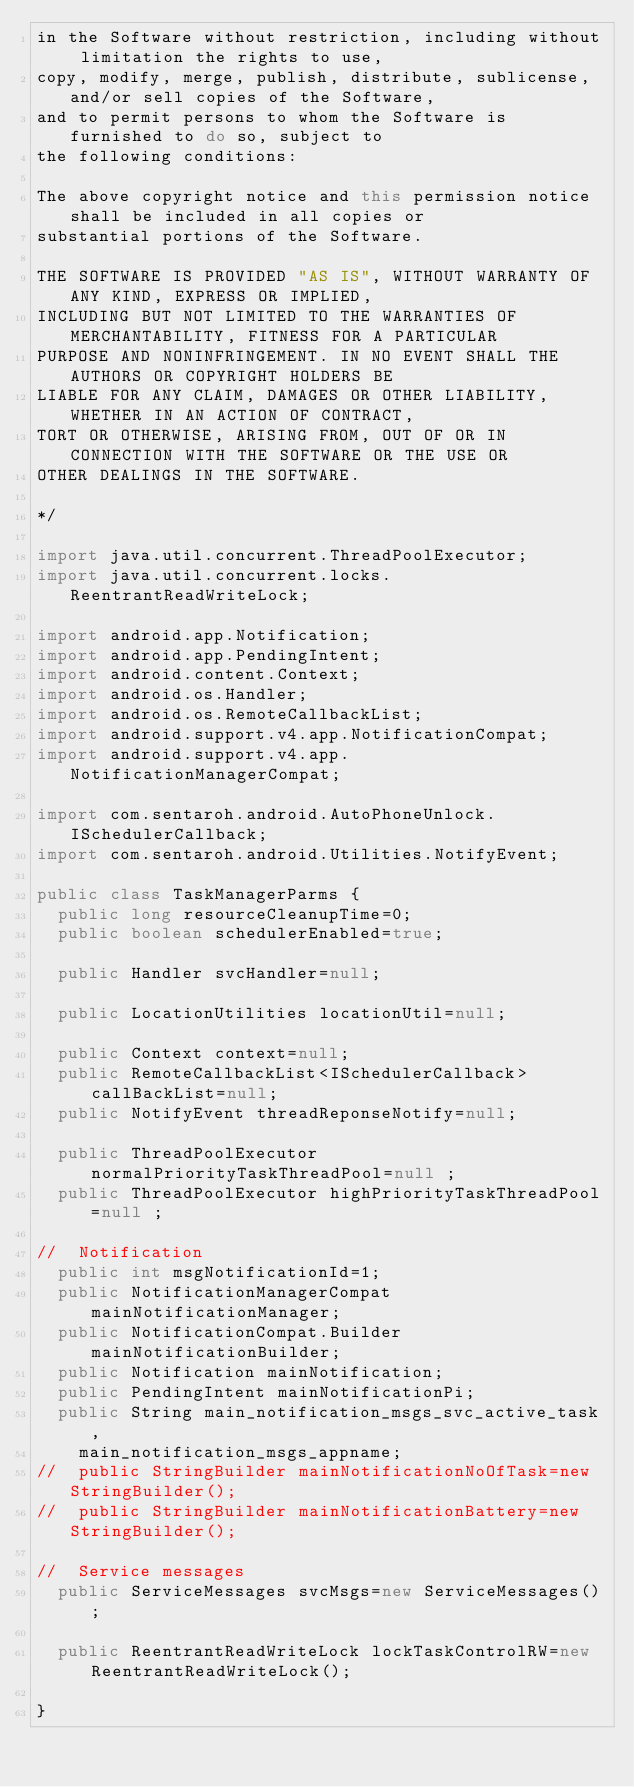<code> <loc_0><loc_0><loc_500><loc_500><_Java_>in the Software without restriction, including without limitation the rights to use,
copy, modify, merge, publish, distribute, sublicense, and/or sell copies of the Software,
and to permit persons to whom the Software is furnished to do so, subject to 
the following conditions:

The above copyright notice and this permission notice shall be included in all copies or 
substantial portions of the Software.

THE SOFTWARE IS PROVIDED "AS IS", WITHOUT WARRANTY OF ANY KIND, EXPRESS OR IMPLIED, 
INCLUDING BUT NOT LIMITED TO THE WARRANTIES OF MERCHANTABILITY, FITNESS FOR A PARTICULAR 
PURPOSE AND NONINFRINGEMENT. IN NO EVENT SHALL THE AUTHORS OR COPYRIGHT HOLDERS BE 
LIABLE FOR ANY CLAIM, DAMAGES OR OTHER LIABILITY, WHETHER IN AN ACTION OF CONTRACT, 
TORT OR OTHERWISE, ARISING FROM, OUT OF OR IN CONNECTION WITH THE SOFTWARE OR THE USE OR
OTHER DEALINGS IN THE SOFTWARE.

*/

import java.util.concurrent.ThreadPoolExecutor;
import java.util.concurrent.locks.ReentrantReadWriteLock;

import android.app.Notification;
import android.app.PendingIntent;
import android.content.Context;
import android.os.Handler;
import android.os.RemoteCallbackList;
import android.support.v4.app.NotificationCompat;
import android.support.v4.app.NotificationManagerCompat;

import com.sentaroh.android.AutoPhoneUnlock.ISchedulerCallback;
import com.sentaroh.android.Utilities.NotifyEvent;

public class TaskManagerParms {
	public long resourceCleanupTime=0;
	public boolean schedulerEnabled=true;
	
	public Handler svcHandler=null;
	
	public LocationUtilities locationUtil=null;
	
	public Context context=null;
	public RemoteCallbackList<ISchedulerCallback> callBackList=null;
	public NotifyEvent threadReponseNotify=null;
	
	public ThreadPoolExecutor normalPriorityTaskThreadPool=null ;
	public ThreadPoolExecutor highPriorityTaskThreadPool=null ;

//	Notification
	public int msgNotificationId=1;
	public NotificationManagerCompat mainNotificationManager; 
	public NotificationCompat.Builder mainNotificationBuilder;
	public Notification mainNotification;
	public PendingIntent mainNotificationPi;
	public String main_notification_msgs_svc_active_task,
		main_notification_msgs_appname;
//	public StringBuilder mainNotificationNoOfTask=new StringBuilder();
//	public StringBuilder mainNotificationBattery=new StringBuilder();
	
//	Service messages
	public ServiceMessages svcMsgs=new ServiceMessages();
	
	public ReentrantReadWriteLock lockTaskControlRW=new ReentrantReadWriteLock();

}
</code> 